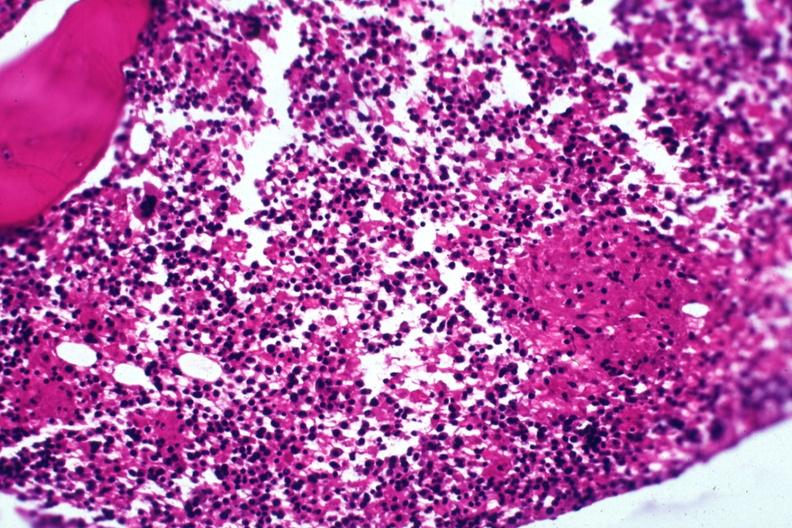s miliary tuberculosis present?
Answer the question using a single word or phrase. Yes 